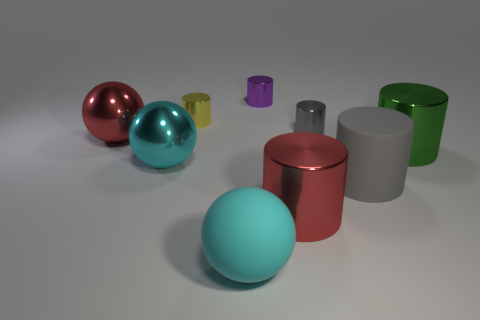Add 1 tiny red cylinders. How many objects exist? 10 Subtract all gray metal cylinders. How many cylinders are left? 5 Subtract all gray balls. How many gray cylinders are left? 2 Subtract all purple cylinders. How many cylinders are left? 5 Subtract all cylinders. How many objects are left? 3 Subtract 1 purple cylinders. How many objects are left? 8 Subtract all yellow balls. Subtract all brown cubes. How many balls are left? 3 Subtract all big red objects. Subtract all big rubber things. How many objects are left? 5 Add 2 matte objects. How many matte objects are left? 4 Add 1 big red metallic cylinders. How many big red metallic cylinders exist? 2 